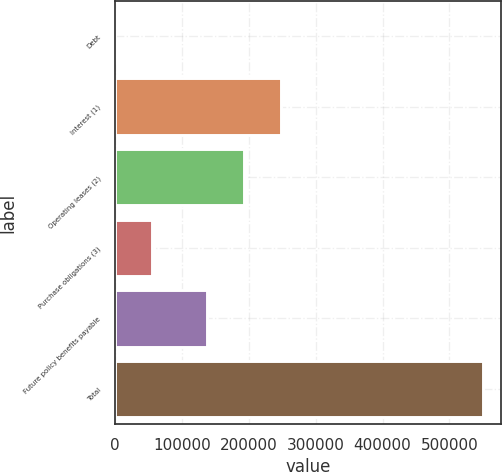<chart> <loc_0><loc_0><loc_500><loc_500><bar_chart><fcel>Debt<fcel>Interest (1)<fcel>Operating leases (2)<fcel>Purchase obligations (3)<fcel>Future policy benefits payable<fcel>Total<nl><fcel>125<fcel>247976<fcel>193027<fcel>55074.2<fcel>138078<fcel>549617<nl></chart> 